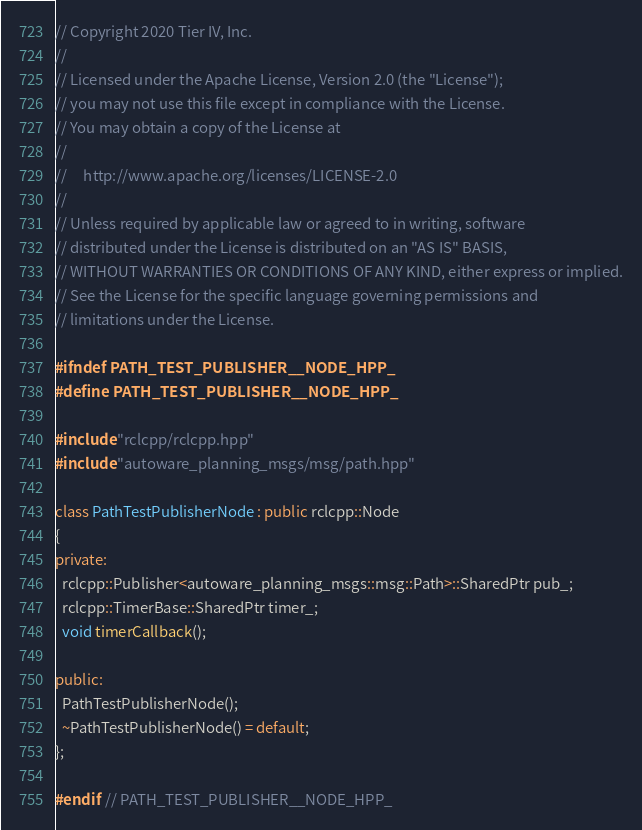Convert code to text. <code><loc_0><loc_0><loc_500><loc_500><_C++_>// Copyright 2020 Tier IV, Inc.
//
// Licensed under the Apache License, Version 2.0 (the "License");
// you may not use this file except in compliance with the License.
// You may obtain a copy of the License at
//
//     http://www.apache.org/licenses/LICENSE-2.0
//
// Unless required by applicable law or agreed to in writing, software
// distributed under the License is distributed on an "AS IS" BASIS,
// WITHOUT WARRANTIES OR CONDITIONS OF ANY KIND, either express or implied.
// See the License for the specific language governing permissions and
// limitations under the License.

#ifndef PATH_TEST_PUBLISHER__NODE_HPP_
#define PATH_TEST_PUBLISHER__NODE_HPP_

#include "rclcpp/rclcpp.hpp"
#include "autoware_planning_msgs/msg/path.hpp"

class PathTestPublisherNode : public rclcpp::Node
{
private:
  rclcpp::Publisher<autoware_planning_msgs::msg::Path>::SharedPtr pub_;
  rclcpp::TimerBase::SharedPtr timer_;
  void timerCallback();

public:
  PathTestPublisherNode();
  ~PathTestPublisherNode() = default;
};

#endif  // PATH_TEST_PUBLISHER__NODE_HPP_
</code> 